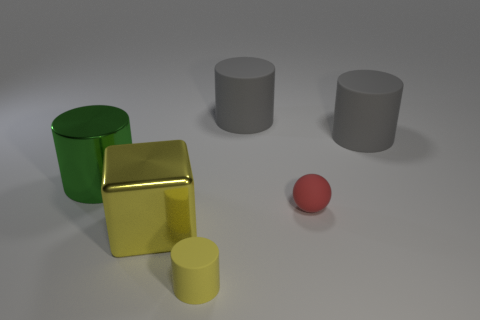Is there anything else that is the same shape as the red rubber thing? Although I cannot determine material properties from the image, based on visible shapes, there are no other objects with the exact same spherical shape as the red object. The others include a green cylinder, a golden cube, a yellow cylinder smaller in height, and two grey cylinders of identical dimensions. 